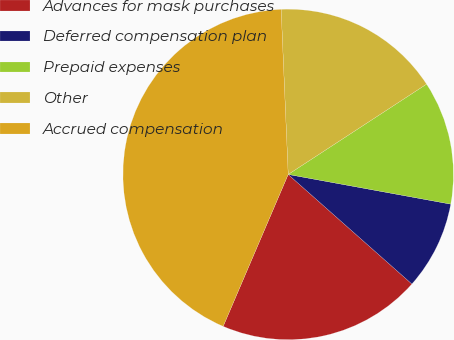Convert chart. <chart><loc_0><loc_0><loc_500><loc_500><pie_chart><fcel>Advances for mask purchases<fcel>Deferred compensation plan<fcel>Prepaid expenses<fcel>Other<fcel>Accrued compensation<nl><fcel>19.9%<fcel>8.66%<fcel>12.08%<fcel>16.48%<fcel>42.88%<nl></chart> 